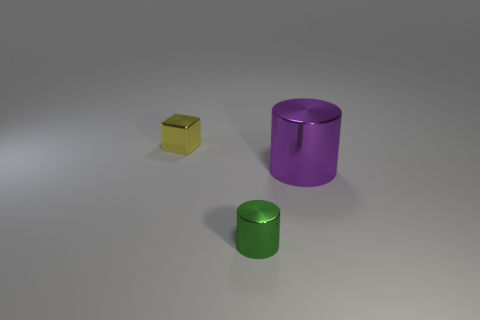What number of other shiny objects are the same shape as the purple thing?
Provide a succinct answer. 1. What is the size of the green object that is the same material as the tiny cube?
Keep it short and to the point. Small. There is a tiny metal thing that is right of the small object behind the tiny cylinder; are there any tiny yellow metal cubes on the right side of it?
Provide a succinct answer. No. There is a shiny cylinder to the left of the purple cylinder; is it the same size as the purple cylinder?
Give a very brief answer. No. How many green metallic objects are the same size as the yellow shiny thing?
Provide a short and direct response. 1. The green thing has what shape?
Offer a terse response. Cylinder. Is the number of purple shiny things that are in front of the yellow metal block greater than the number of small blue matte spheres?
Ensure brevity in your answer.  Yes. There is a large thing; does it have the same shape as the shiny thing that is in front of the purple object?
Your answer should be compact. Yes. Is there a gray rubber thing?
Offer a terse response. No. How many big objects are either shiny blocks or shiny cylinders?
Give a very brief answer. 1. 